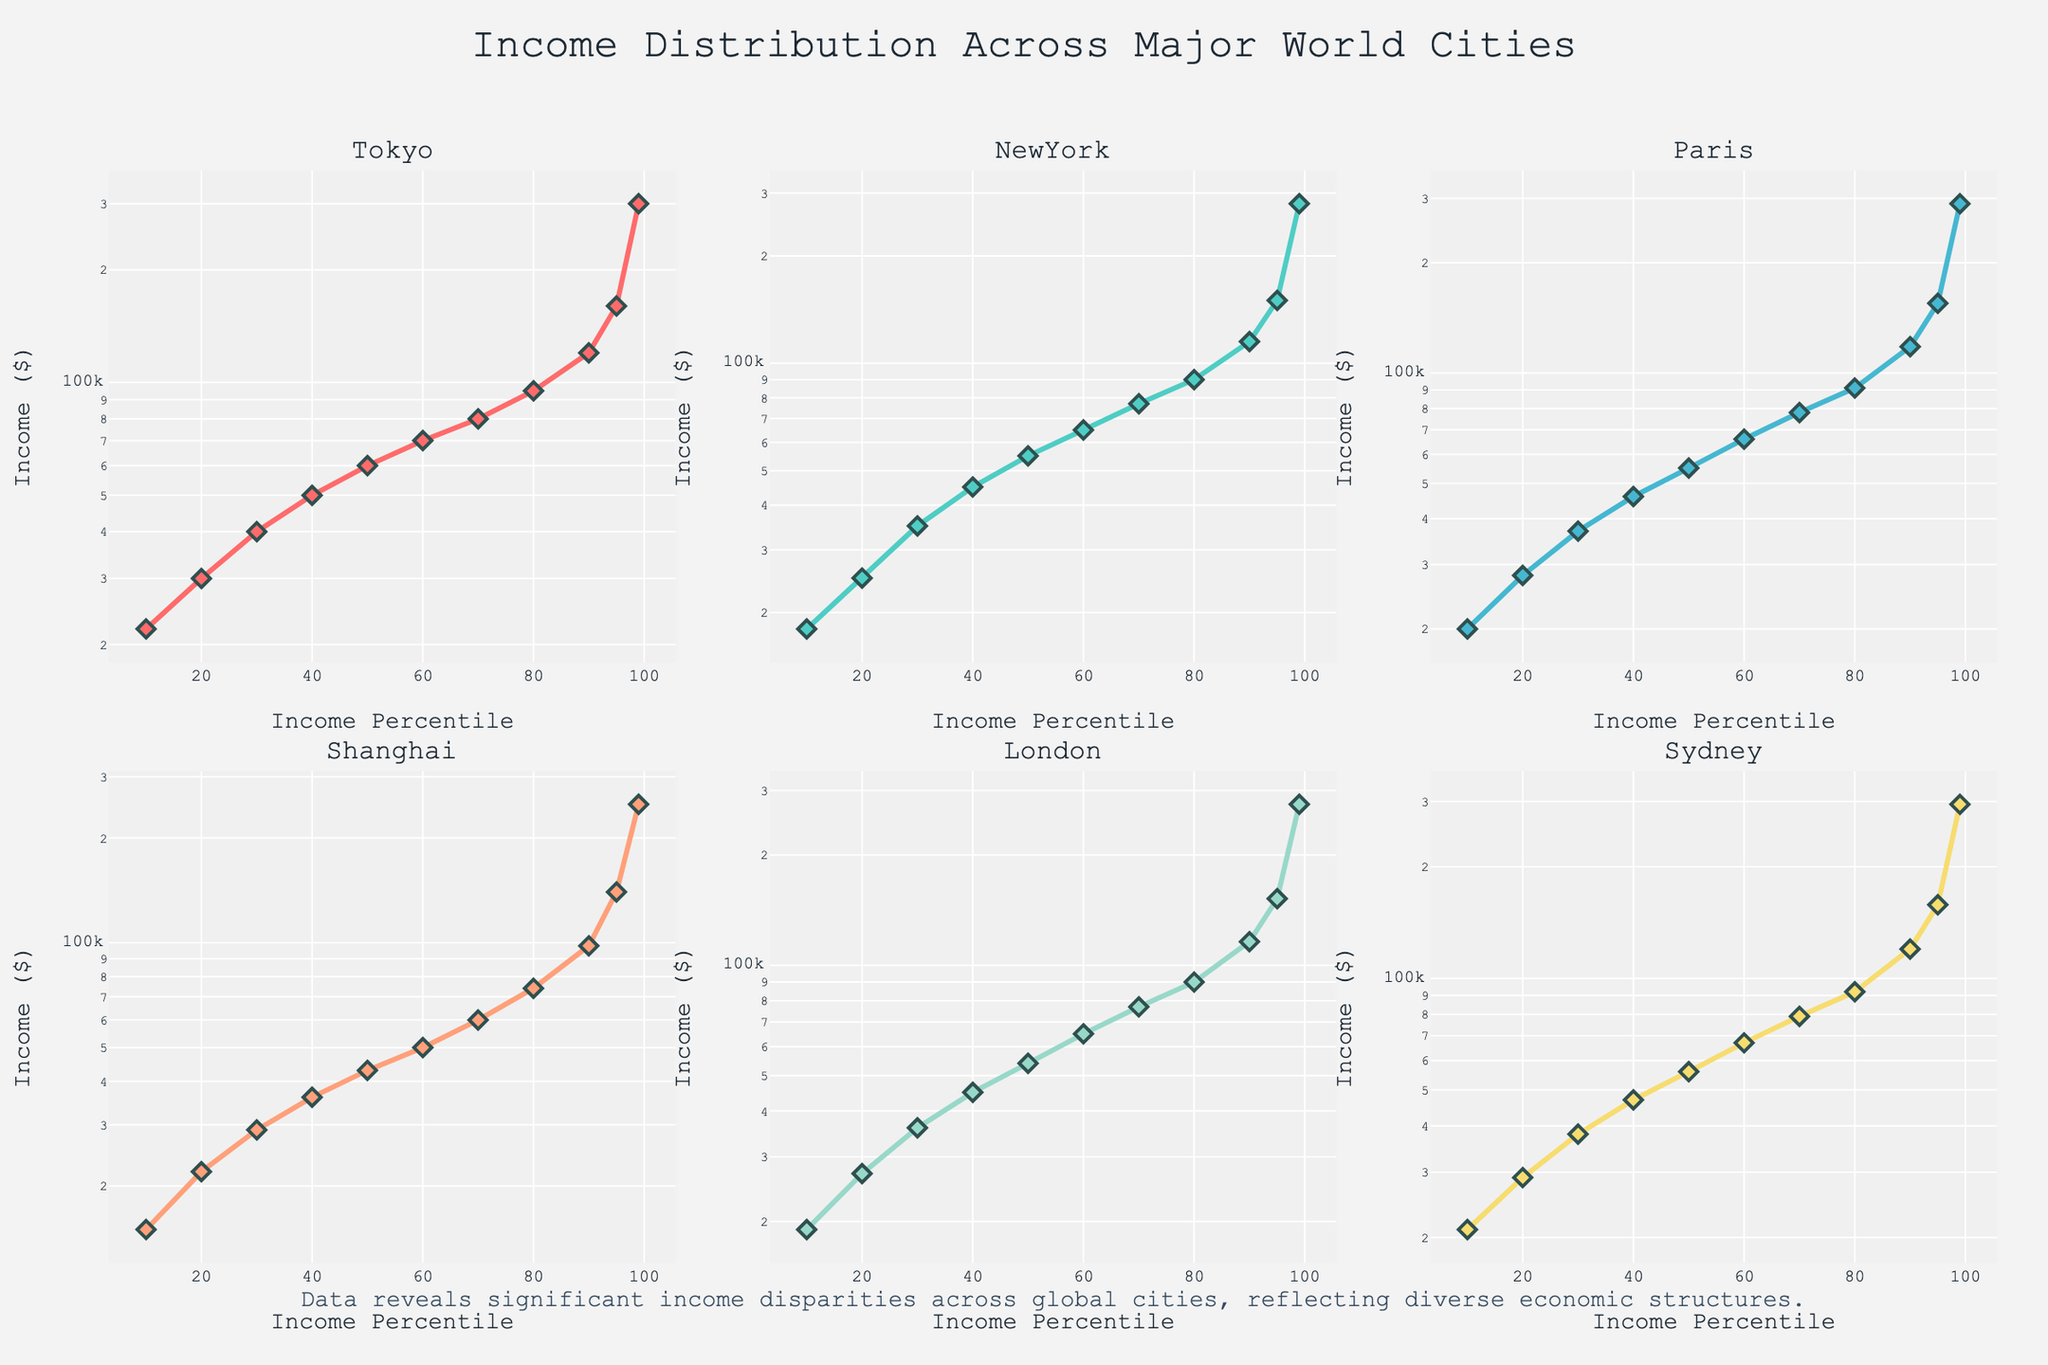What is the title of the figure? The title is located at the top center of the figure, in a large font size, and reads "Income Distribution Across Major World Cities".
Answer: Income Distribution Across Major World Cities What type of axis is used for the y-axis in these subplots? Each subplot's y-axis has a logarithmic scale, which is indicated by the y-axis title "Income ($)" combined with the non-linear spacing of the tick marks.
Answer: Logarithmic Which city has the highest income at the 99th percentile? To determine the highest income at the 99th percentile across cities, you need to compare the log-scale y-values of the 99th percentile points in each subplot. The city with the highest y-value is Tokyo, with $300,000.
Answer: Tokyo Is there a significant difference in income for the 95th percentile between New York and Paris? Compare the y-values (income) of the 95th percentiles for New York and Paris. New York's 95th percentile income is $150,000, while Paris's is $155,000. The difference is $5,000.
Answer: Yes, $5,000 How does the income at the 10th percentile in Shanghai compare to Sydney? Look at the y-values for the 10th percentile in both the Shanghai and Sydney subplots. Shanghai's 10th percentile income is $15,000, while Sydney’s is $21,000.
Answer: Shanghai’s is lower, $15,000 vs. $21,000 Which city shows the largest spread between the 10th and 99th percentiles? Calculate the difference between the 10th and 99th percentile incomes for each city and compare. For Tokyo: $300,000 - $22,000 = $278,000, New York: $280,000 - $18,000 = $262,000, Paris: $290,000 - $20,000 = $270,000, Shanghai: $250,000 - $15,000 = $235,000, London: $275,000 - $19,000 = $256,000, Sydney: $295,000 - $21,000 = $274,000. Tokyo has the largest spread.
Answer: Tokyo, $278,000 Are income differences more pronounced in higher percentiles or lower percentiles across all cities? By observing the shapes and slopes of the lines in each subplot, you can see that the lines are steeper in the higher percentiles, indicating larger differences in income distribution.
Answer: Higher percentiles What message does the annotation at the bottom of the figure convey? The annotation text is placed below the subplot grid and states, "Data reveals significant income disparities across global cities, reflecting diverse economic structures." It suggests that the plot highlights the income inequality among different cities.
Answer: It highlights income disparities across cities 